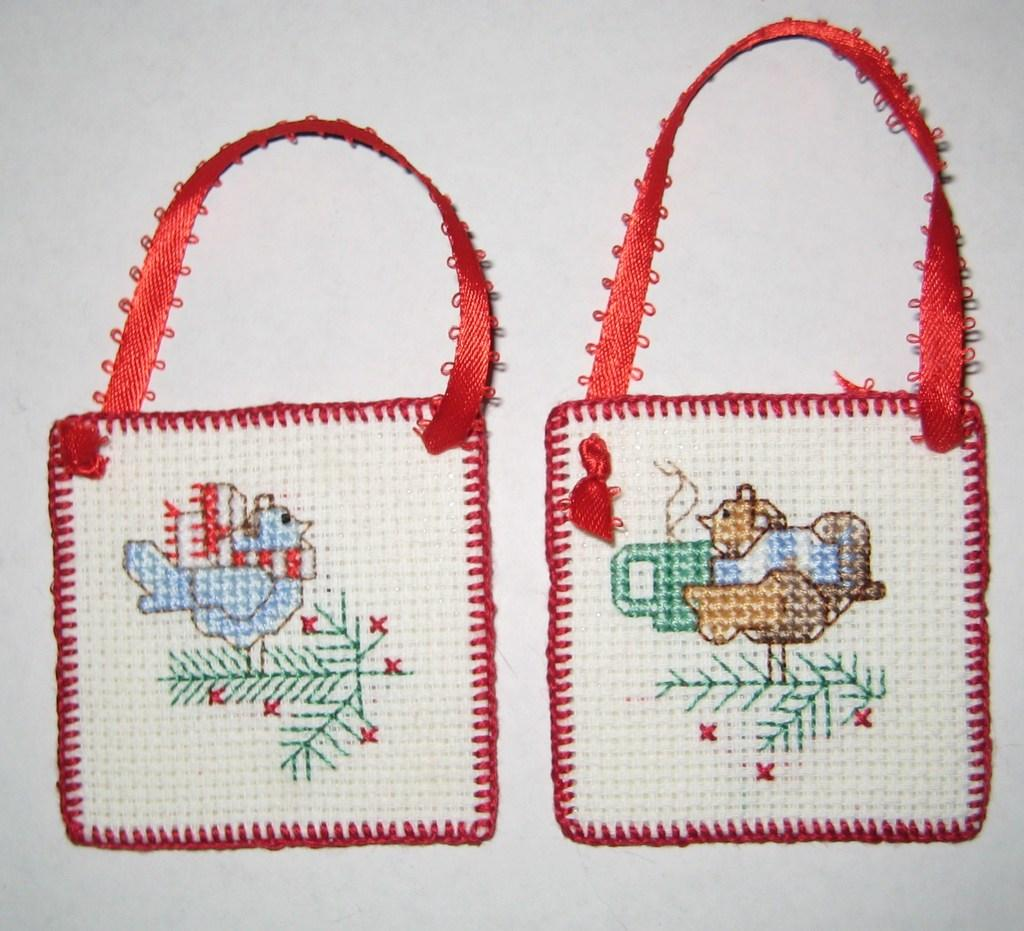What objects can be seen in the image? There are bags in the image. How are the bags positioned in the image? The bags are placed. What type of interest is being generated by the bags in the image? There is no indication of interest or any financial aspect related to the bags in the image. 